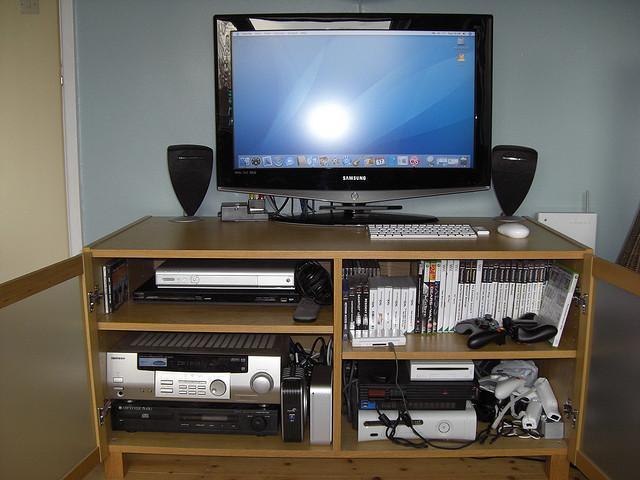What is the purpose of this setup?
From the following set of four choices, select the accurate answer to respond to the question.
Options: Physical enhancement, sustenance, physical pleasure, entertainment. Entertainment. 